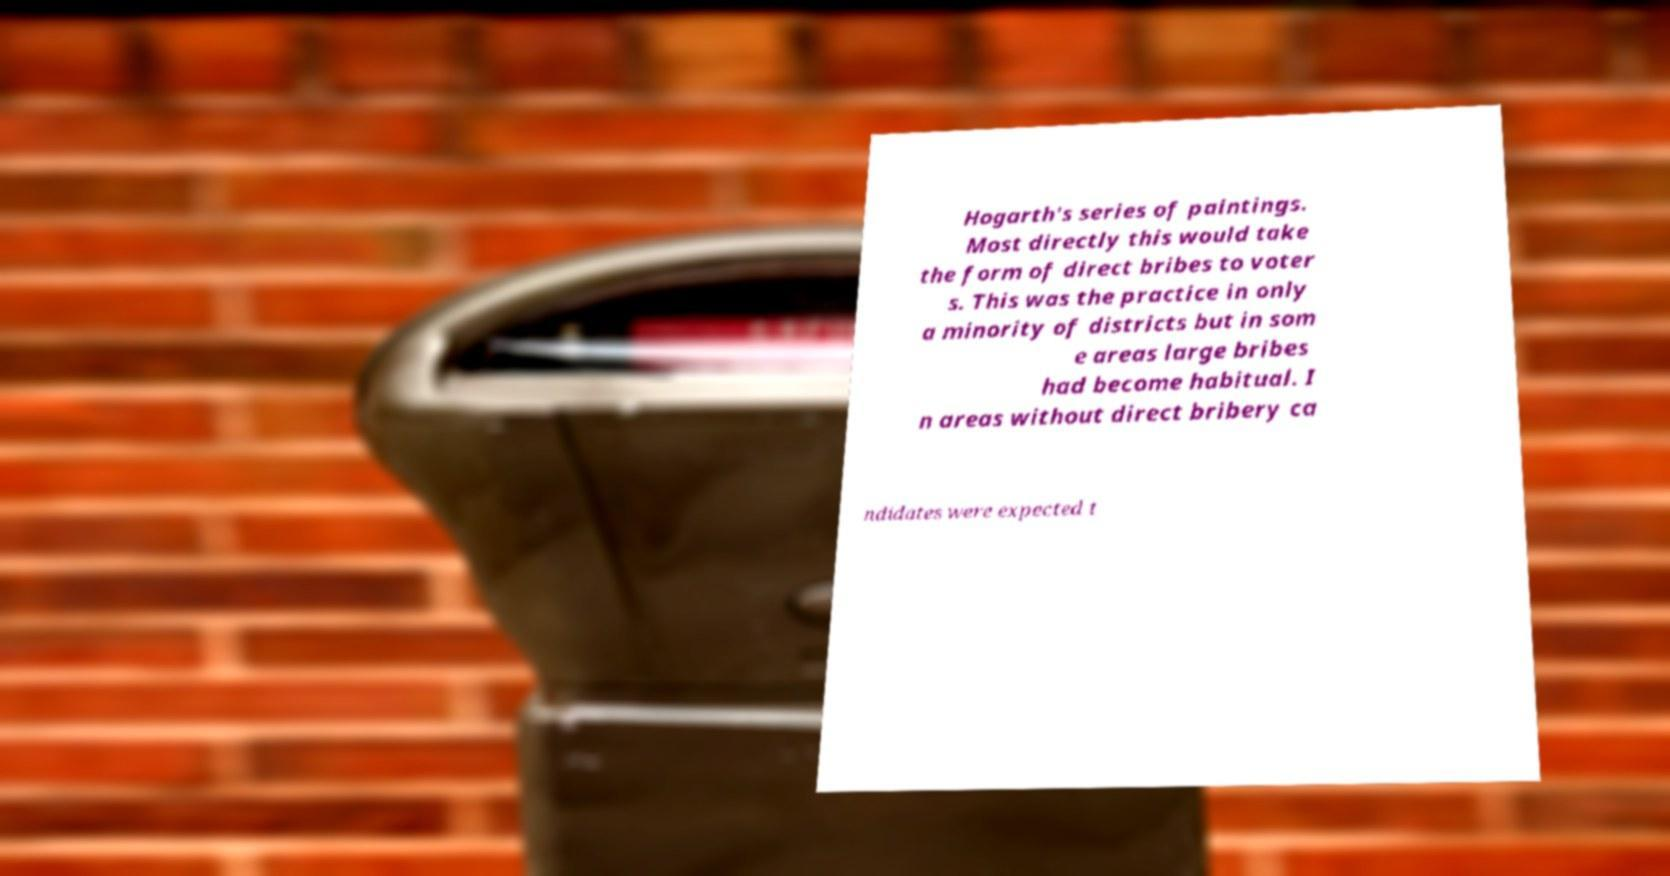What messages or text are displayed in this image? I need them in a readable, typed format. Hogarth's series of paintings. Most directly this would take the form of direct bribes to voter s. This was the practice in only a minority of districts but in som e areas large bribes had become habitual. I n areas without direct bribery ca ndidates were expected t 